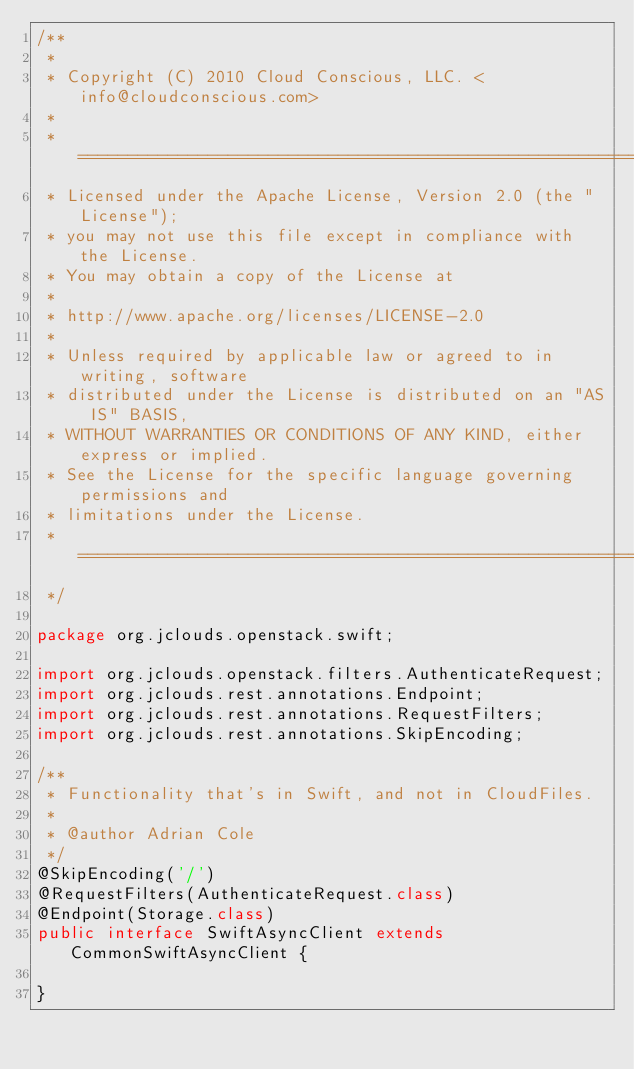<code> <loc_0><loc_0><loc_500><loc_500><_Java_>/**
 *
 * Copyright (C) 2010 Cloud Conscious, LLC. <info@cloudconscious.com>
 *
 * ====================================================================
 * Licensed under the Apache License, Version 2.0 (the "License");
 * you may not use this file except in compliance with the License.
 * You may obtain a copy of the License at
 *
 * http://www.apache.org/licenses/LICENSE-2.0
 *
 * Unless required by applicable law or agreed to in writing, software
 * distributed under the License is distributed on an "AS IS" BASIS,
 * WITHOUT WARRANTIES OR CONDITIONS OF ANY KIND, either express or implied.
 * See the License for the specific language governing permissions and
 * limitations under the License.
 * ====================================================================
 */

package org.jclouds.openstack.swift;

import org.jclouds.openstack.filters.AuthenticateRequest;
import org.jclouds.rest.annotations.Endpoint;
import org.jclouds.rest.annotations.RequestFilters;
import org.jclouds.rest.annotations.SkipEncoding;

/**
 * Functionality that's in Swift, and not in CloudFiles.
 * 
 * @author Adrian Cole
 */
@SkipEncoding('/')
@RequestFilters(AuthenticateRequest.class)
@Endpoint(Storage.class)
public interface SwiftAsyncClient extends CommonSwiftAsyncClient {

}
</code> 